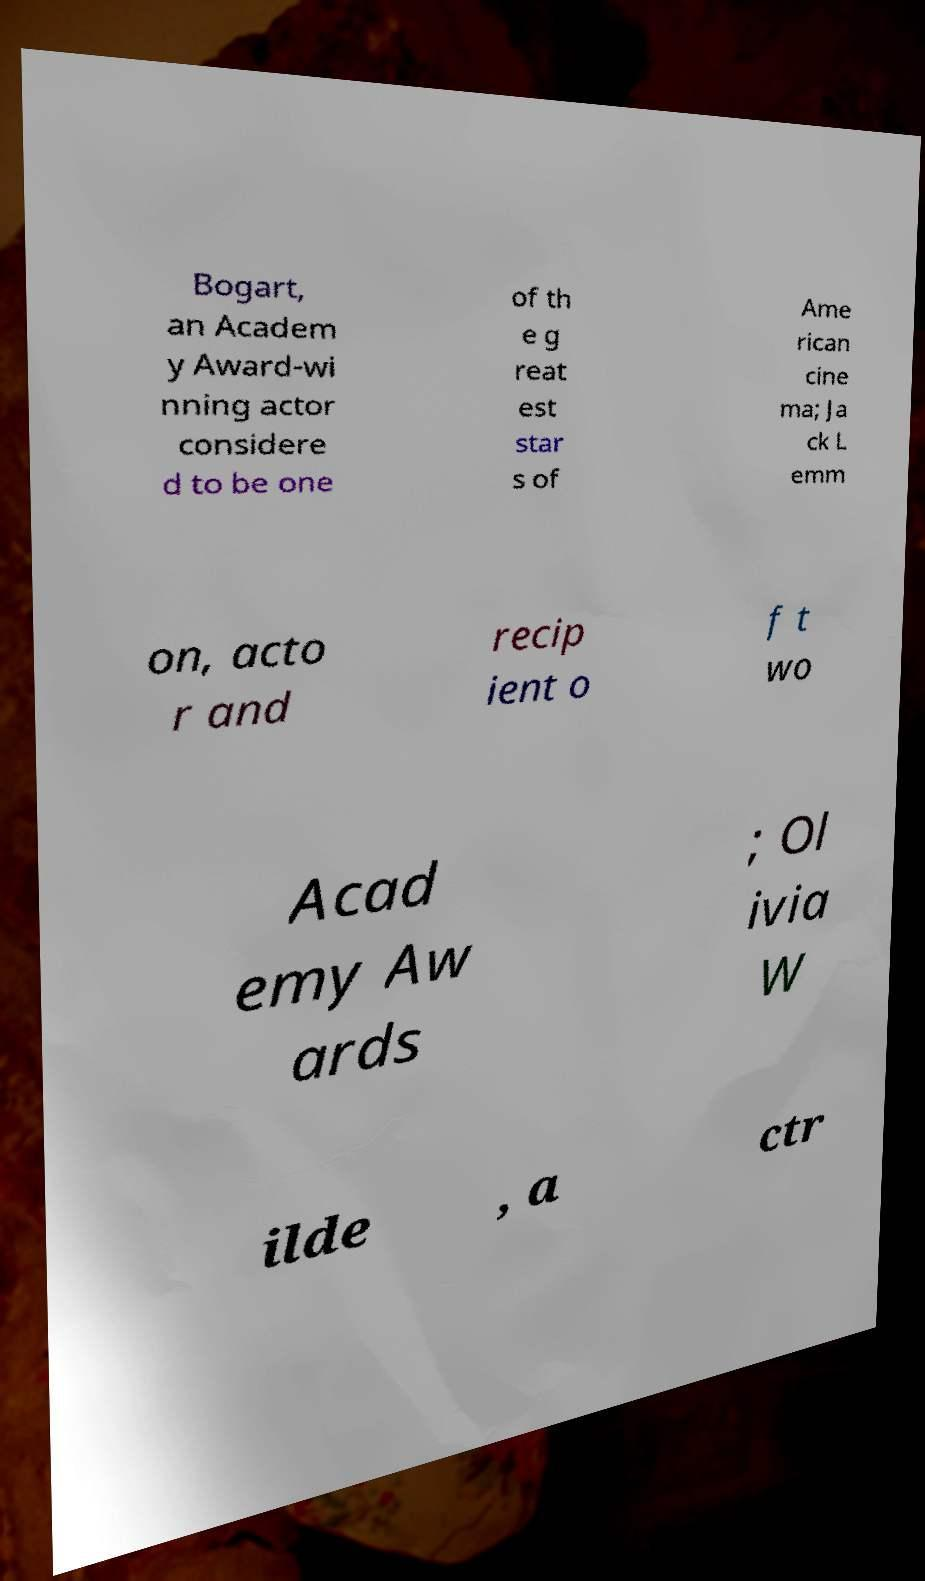What messages or text are displayed in this image? I need them in a readable, typed format. Bogart, an Academ y Award-wi nning actor considere d to be one of th e g reat est star s of Ame rican cine ma; Ja ck L emm on, acto r and recip ient o f t wo Acad emy Aw ards ; Ol ivia W ilde , a ctr 